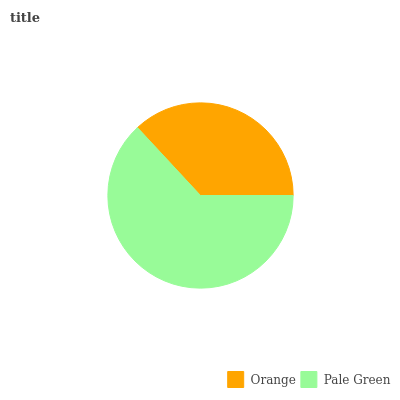Is Orange the minimum?
Answer yes or no. Yes. Is Pale Green the maximum?
Answer yes or no. Yes. Is Pale Green the minimum?
Answer yes or no. No. Is Pale Green greater than Orange?
Answer yes or no. Yes. Is Orange less than Pale Green?
Answer yes or no. Yes. Is Orange greater than Pale Green?
Answer yes or no. No. Is Pale Green less than Orange?
Answer yes or no. No. Is Pale Green the high median?
Answer yes or no. Yes. Is Orange the low median?
Answer yes or no. Yes. Is Orange the high median?
Answer yes or no. No. Is Pale Green the low median?
Answer yes or no. No. 